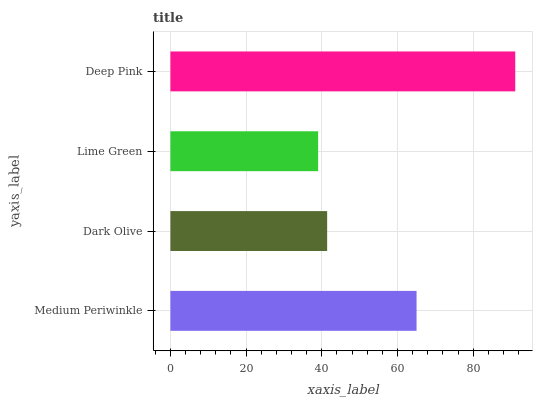Is Lime Green the minimum?
Answer yes or no. Yes. Is Deep Pink the maximum?
Answer yes or no. Yes. Is Dark Olive the minimum?
Answer yes or no. No. Is Dark Olive the maximum?
Answer yes or no. No. Is Medium Periwinkle greater than Dark Olive?
Answer yes or no. Yes. Is Dark Olive less than Medium Periwinkle?
Answer yes or no. Yes. Is Dark Olive greater than Medium Periwinkle?
Answer yes or no. No. Is Medium Periwinkle less than Dark Olive?
Answer yes or no. No. Is Medium Periwinkle the high median?
Answer yes or no. Yes. Is Dark Olive the low median?
Answer yes or no. Yes. Is Lime Green the high median?
Answer yes or no. No. Is Lime Green the low median?
Answer yes or no. No. 